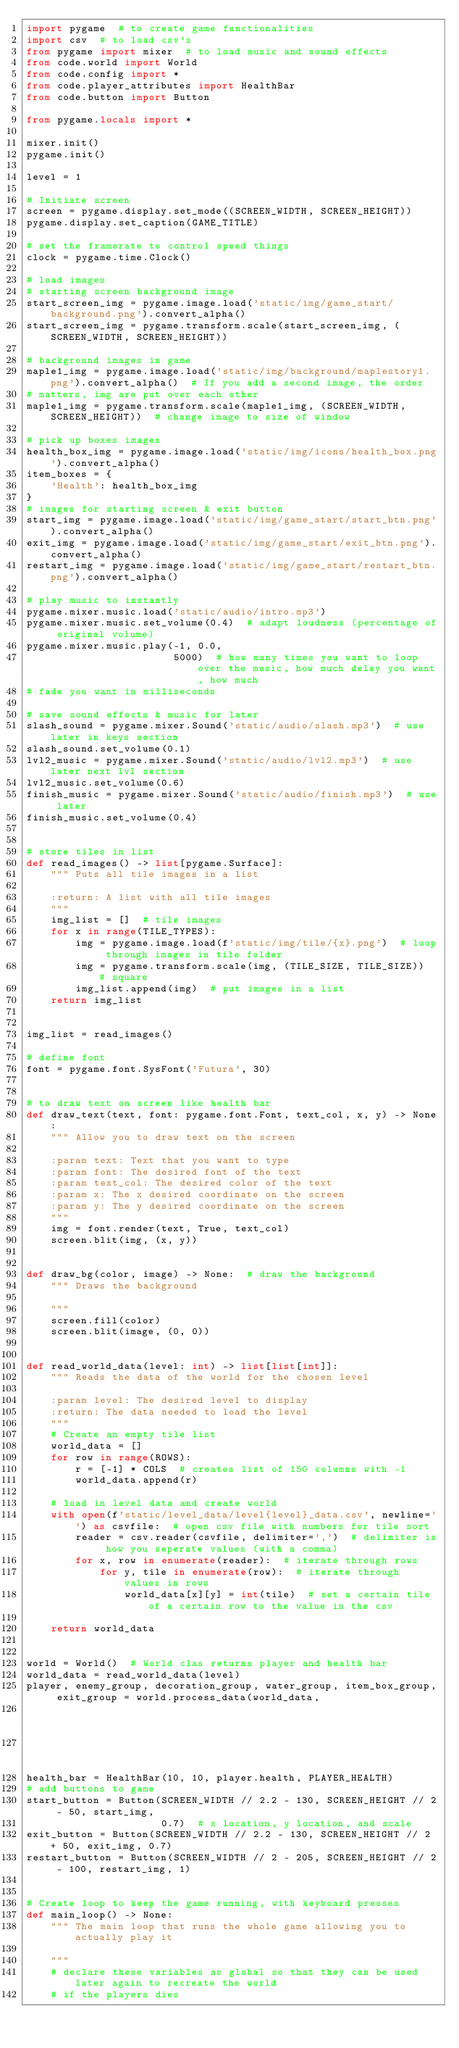<code> <loc_0><loc_0><loc_500><loc_500><_Python_>import pygame  # to create game functionalities
import csv  # to load csv's
from pygame import mixer  # to load music and sound effects
from code.world import World
from code.config import *
from code.player_attributes import HealthBar
from code.button import Button

from pygame.locals import *

mixer.init()
pygame.init()

level = 1

# Initiate screen
screen = pygame.display.set_mode((SCREEN_WIDTH, SCREEN_HEIGHT))
pygame.display.set_caption(GAME_TITLE)

# set the framerate to control speed things
clock = pygame.time.Clock()

# load images
# starting screen background image
start_screen_img = pygame.image.load('static/img/game_start/background.png').convert_alpha()
start_screen_img = pygame.transform.scale(start_screen_img, (SCREEN_WIDTH, SCREEN_HEIGHT))

# background images in game
maple1_img = pygame.image.load('static/img/background/maplestory1.png').convert_alpha()  # If you add a second image, the order
# matters, img are put over each other
maple1_img = pygame.transform.scale(maple1_img, (SCREEN_WIDTH, SCREEN_HEIGHT))  # change image to size of window

# pick up boxes images
health_box_img = pygame.image.load('static/img/icons/health_box.png').convert_alpha()
item_boxes = {
    'Health': health_box_img
}
# images for starting screen & exit button
start_img = pygame.image.load('static/img/game_start/start_btn.png').convert_alpha()
exit_img = pygame.image.load('static/img/game_start/exit_btn.png').convert_alpha()
restart_img = pygame.image.load('static/img/game_start/restart_btn.png').convert_alpha()

# play music to instantly
pygame.mixer.music.load('static/audio/intro.mp3')
pygame.mixer.music.set_volume(0.4)  # adapt loudness (percentage of original volume)
pygame.mixer.music.play(-1, 0.0,
                        5000)  # how many times you want to loop over the music, how much delay you want, how much
# fade you want in milliseconds

# save sound effects & music for later
slash_sound = pygame.mixer.Sound('static/audio/slash.mp3')  # use later in keys section
slash_sound.set_volume(0.1)
lvl2_music = pygame.mixer.Sound('static/audio/lvl2.mp3')  # use later next lvl section
lvl2_music.set_volume(0.6)
finish_music = pygame.mixer.Sound('static/audio/finish.mp3')  # use later
finish_music.set_volume(0.4)


# store tiles in list
def read_images() -> list[pygame.Surface]:
    """ Puts all tile images in a list

    :return: A list with all tile images
    """
    img_list = []  # tile images
    for x in range(TILE_TYPES):
        img = pygame.image.load(f'static/img/tile/{x}.png')  # loop through images in tile folder
        img = pygame.transform.scale(img, (TILE_SIZE, TILE_SIZE))  # square
        img_list.append(img)  # put images in a list
    return img_list


img_list = read_images()

# define font
font = pygame.font.SysFont('Futura', 30)


# to draw text on screen like health bar
def draw_text(text, font: pygame.font.Font, text_col, x, y) -> None:
    """ Allow you to draw text on the screen

    :param text: Text that you want to type
    :param font: The desired font of the text
    :param text_col: The desired color of the text
    :param x: The x desired coordinate on the screen
    :param y: The y desired coordinate on the screen
    """
    img = font.render(text, True, text_col)
    screen.blit(img, (x, y))


def draw_bg(color, image) -> None:  # draw the background
    """ Draws the background

    """
    screen.fill(color)
    screen.blit(image, (0, 0))


def read_world_data(level: int) -> list[list[int]]:
    """ Reads the data of the world for the chosen level

    :param level: The desired level to display
    :return: The data needed to load the level
    """
    # Create an empty tile list
    world_data = []
    for row in range(ROWS):
        r = [-1] * COLS  # creates list of 150 columns with -1
        world_data.append(r)

    # load in level data and create world
    with open(f'static/level_data/level{level}_data.csv', newline='') as csvfile:  # open csv file with numbers for tile sort
        reader = csv.reader(csvfile, delimiter=',')  # delimiter is how you seperate values (with a comma)
        for x, row in enumerate(reader):  # iterate through rows
            for y, tile in enumerate(row):  # iterate through values in rows
                world_data[x][y] = int(tile)  # set a certain tile of a certain row to the value in the csv

    return world_data


world = World()  # World clas returns player and health bar
world_data = read_world_data(level)
player, enemy_group, decoration_group, water_group, item_box_group, exit_group = world.process_data(world_data,
                                                                                                    img_list,
                                                                                                    item_boxes)
health_bar = HealthBar(10, 10, player.health, PLAYER_HEALTH)
# add buttons to game
start_button = Button(SCREEN_WIDTH // 2.2 - 130, SCREEN_HEIGHT // 2 - 50, start_img,
                      0.7)  # x location, y location, and scale
exit_button = Button(SCREEN_WIDTH // 2.2 - 130, SCREEN_HEIGHT // 2 + 50, exit_img, 0.7)
restart_button = Button(SCREEN_WIDTH // 2 - 205, SCREEN_HEIGHT // 2 - 100, restart_img, 1)


# Create loop to keep the game running, with keyboard presses
def main_loop() -> None:
    """ The main loop that runs the whole game allowing you to actually play it

    """
    # declare these variables as global so that they can be used later again to recreate the world
    # if the players dies</code> 